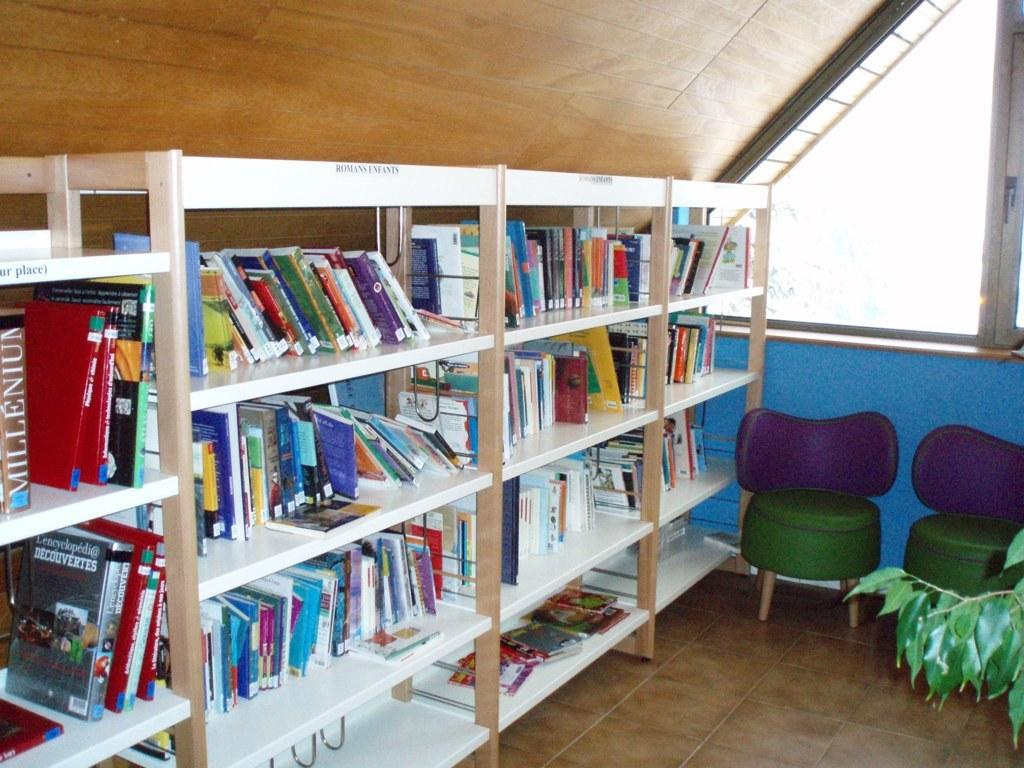What is on the rack in the image? There is a rack filled with books in the image. What can be seen through the window in the image? The presence of a window in the image suggests that there might be a view or outdoor scene visible, but the specifics are not mentioned in the provided facts. How many chairs are in the image? There are two chairs in the image. What type of bucket is hanging on the wall in the image? There is no bucket present in the image. What kind of trouble is the bun experiencing in the image? There is no bun or any indication of trouble in the image. 